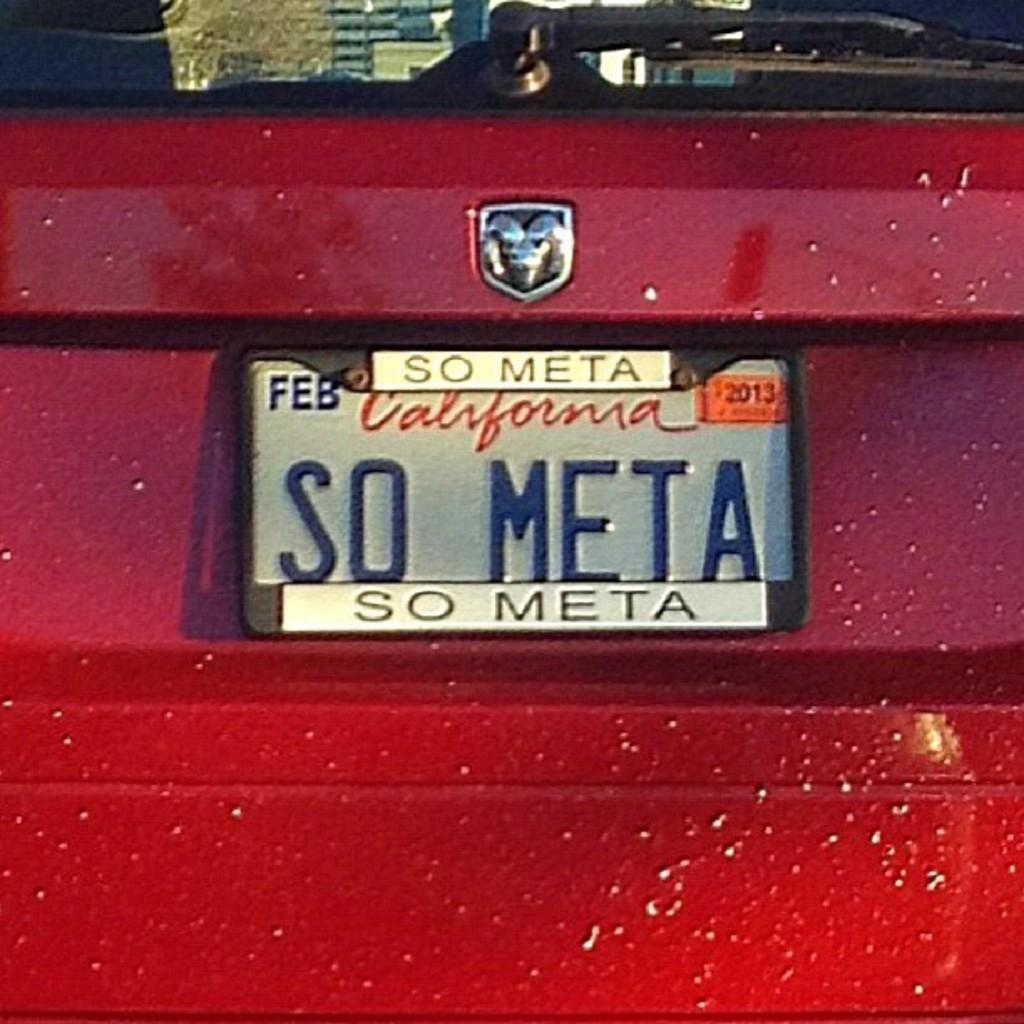<image>
Summarize the visual content of the image. the state of California on a license plate 